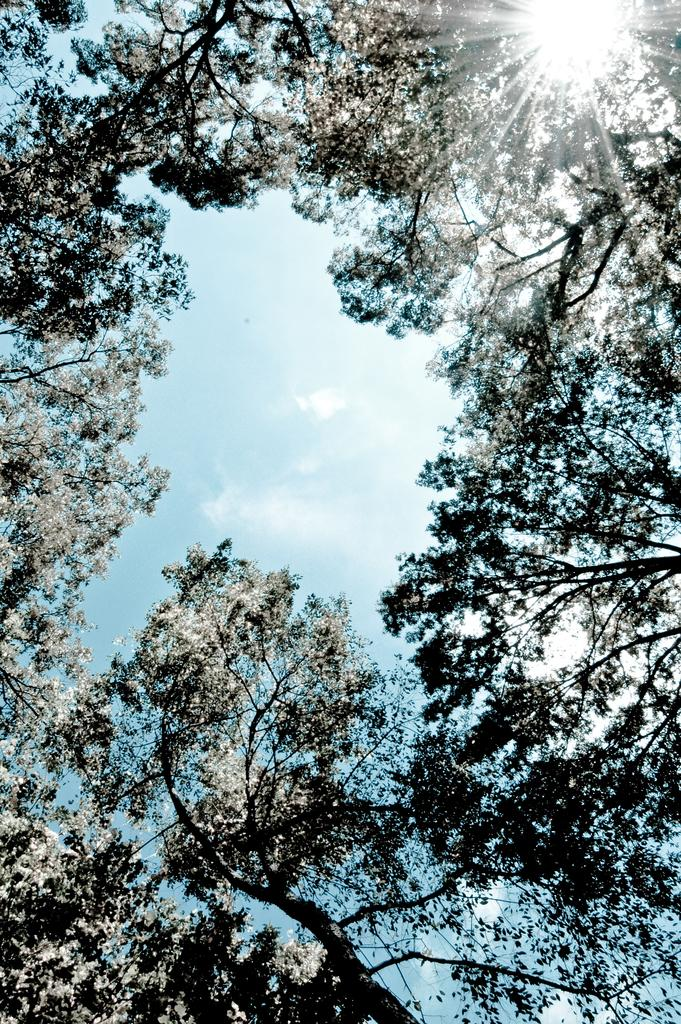What can be seen at the top of the image? The sky is visible in the image. What type of vegetation is present in the image? There are trees in the image. What type of rhythm can be heard in the image? There is no sound or rhythm present in the image, as it is a visual representation. Where is the lunchroom located in the image? There is no mention of a lunchroom in the image, as it only features the sky and trees. 